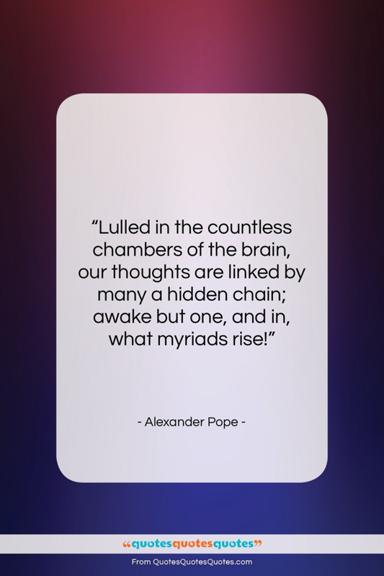What does the quote by Alexander Pope mean? The quote by Alexander Pope captures the wonder of the human thought process. He poetically expresses that within the 'countless chambers of the brain,' our thoughts interconnect in complex ways we may not be consciously aware of. Awakening one thought can lead to a cascade of related thoughts—'what myriads rise,' suggesting a vast and rich inner world, teeming with potential and connections waiting to be explored. 